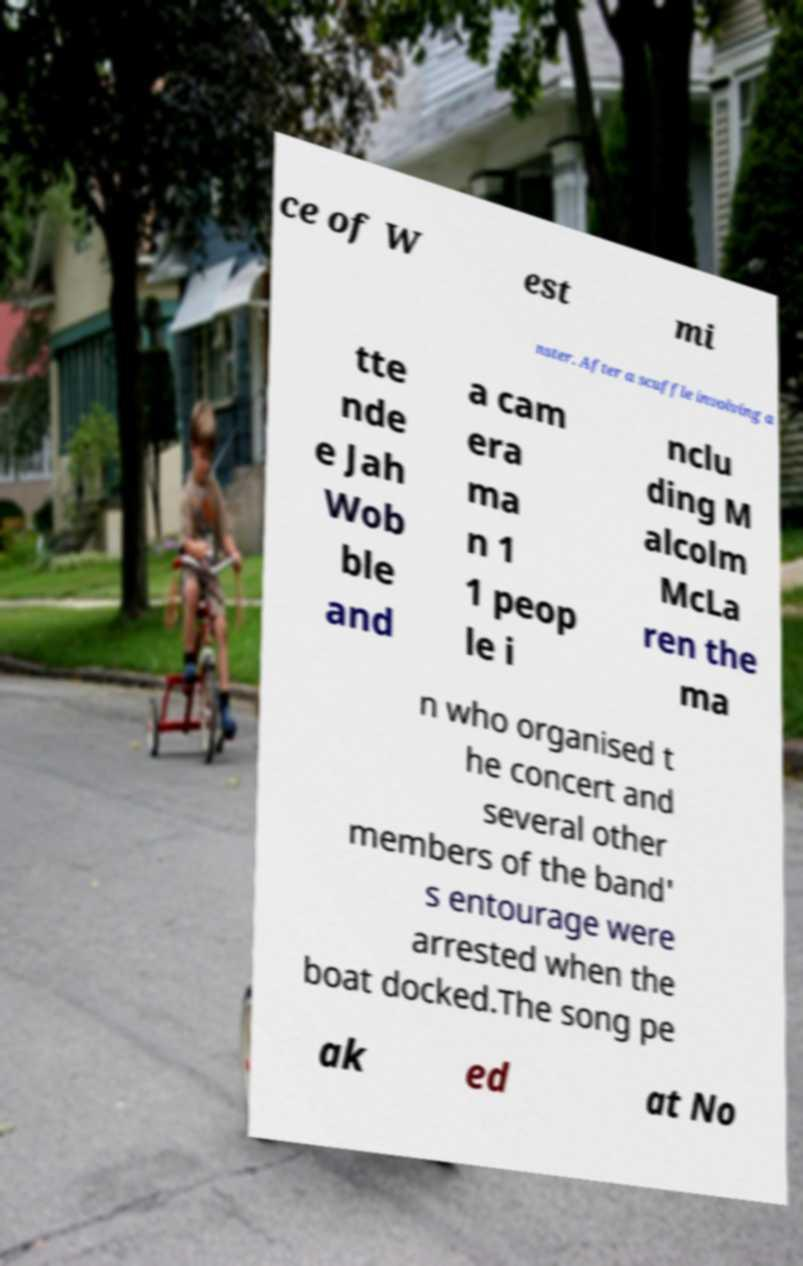Could you assist in decoding the text presented in this image and type it out clearly? ce of W est mi nster. After a scuffle involving a tte nde e Jah Wob ble and a cam era ma n 1 1 peop le i nclu ding M alcolm McLa ren the ma n who organised t he concert and several other members of the band' s entourage were arrested when the boat docked.The song pe ak ed at No 